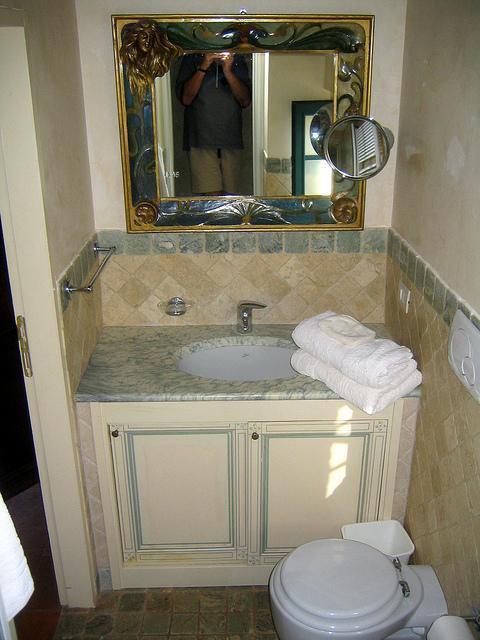What type of mirror is the small circular one referred to as?
Choose the right answer and clarify with the format: 'Answer: answer
Rationale: rationale.'
Options: Circular, make-up, extra, round. Answer: make-up.
Rationale: Traditionally those shape of mirrors are used to get a closeup look at your face. 